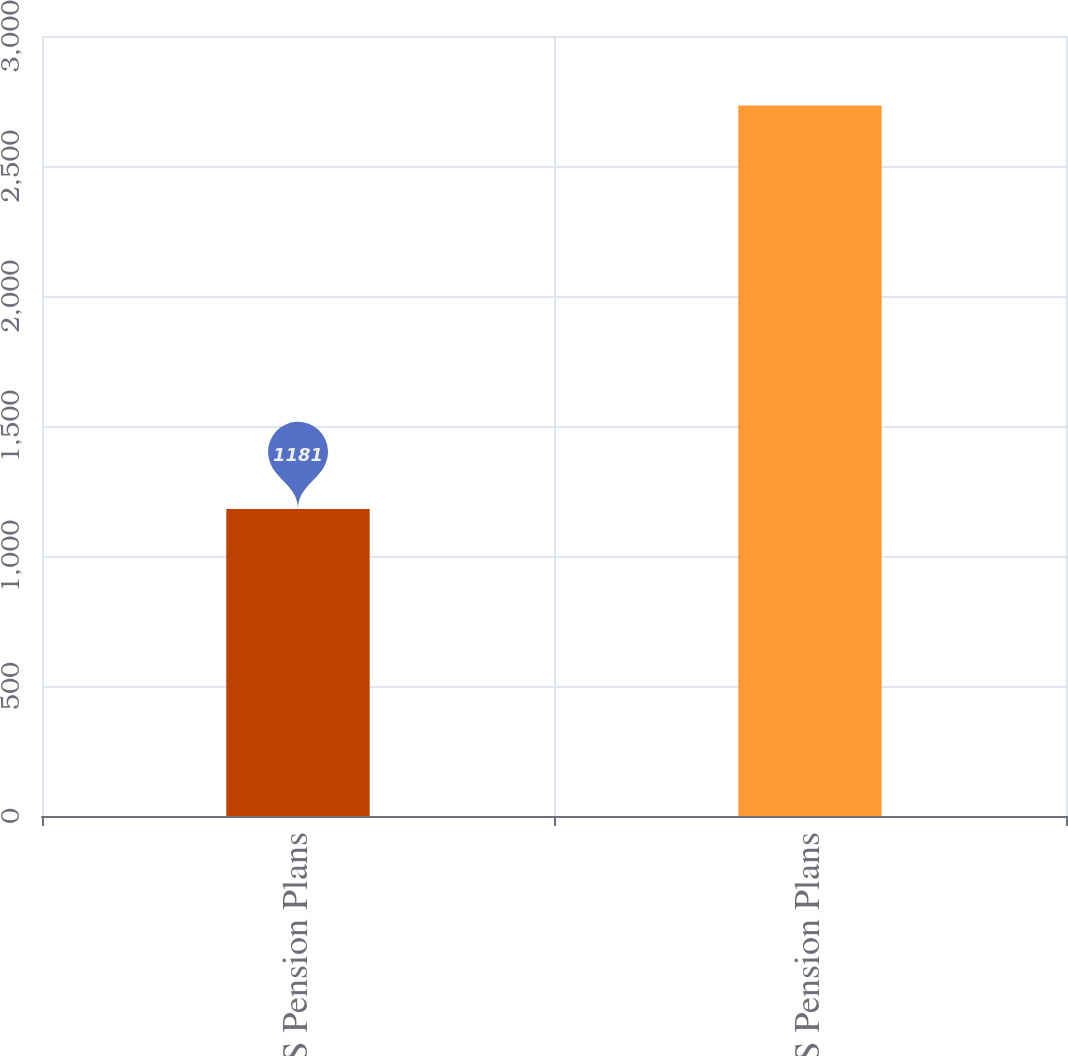Convert chart. <chart><loc_0><loc_0><loc_500><loc_500><bar_chart><fcel>US Pension Plans<fcel>Non-US Pension Plans<nl><fcel>1181<fcel>2733<nl></chart> 